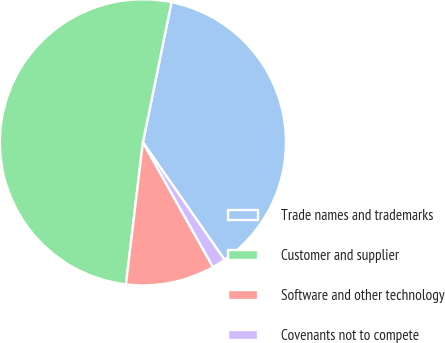Convert chart. <chart><loc_0><loc_0><loc_500><loc_500><pie_chart><fcel>Trade names and trademarks<fcel>Customer and supplier<fcel>Software and other technology<fcel>Covenants not to compete<nl><fcel>37.13%<fcel>51.31%<fcel>10.04%<fcel>1.52%<nl></chart> 